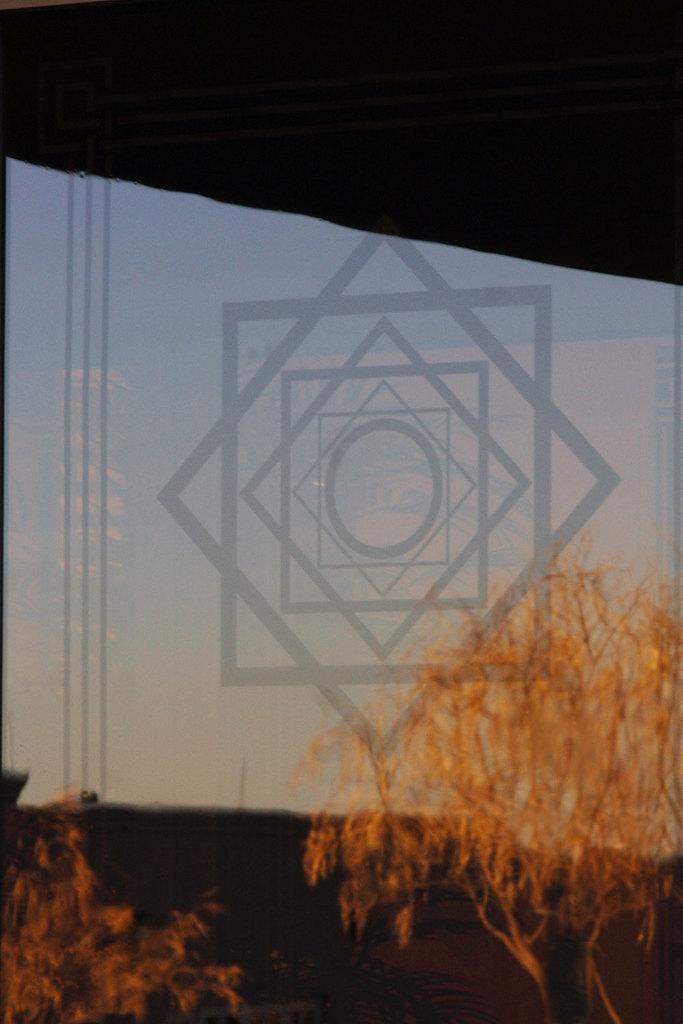What types of vegetation are present at the bottom of the image? There are plants and trees at the bottom of the image. What is located behind the plants and trees? There is a white board or projector screen behind the plants and trees. What color is the background of the image? The background of the image is white in color. Can you see any elbows on the plants or trees in the image? There are no elbows present on the plants or trees in the image, as elbows are a part of the human body and not found on plants or trees. 